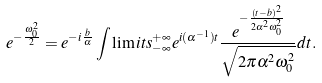Convert formula to latex. <formula><loc_0><loc_0><loc_500><loc_500>e ^ { - \frac { \omega _ { 0 } ^ { 2 } } { 2 } } = e ^ { - i \frac { b } { \alpha } } \int \lim i t s _ { - \infty } ^ { + \infty } e ^ { i ( \alpha ^ { - 1 } ) t } \frac { e ^ { - \frac { ( t - b ) ^ { 2 } } { 2 \alpha ^ { 2 } \omega ^ { 2 } _ { 0 } } } } { \sqrt { 2 \pi \alpha ^ { 2 } \omega ^ { 2 } _ { 0 } } } d t .</formula> 